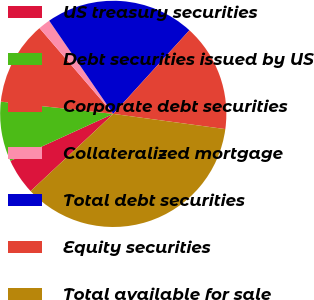Convert chart to OTSL. <chart><loc_0><loc_0><loc_500><loc_500><pie_chart><fcel>US treasury securities<fcel>Debt securities issued by US<fcel>Corporate debt securities<fcel>Collateralized mortgage<fcel>Total debt securities<fcel>Equity securities<fcel>Total available for sale<nl><fcel>5.14%<fcel>8.55%<fcel>11.97%<fcel>1.72%<fcel>21.34%<fcel>15.39%<fcel>35.89%<nl></chart> 